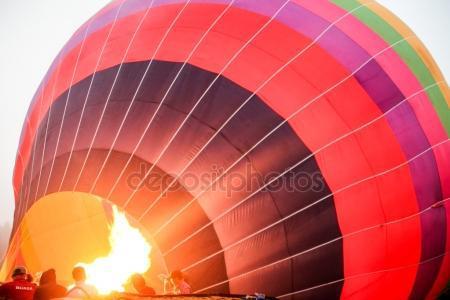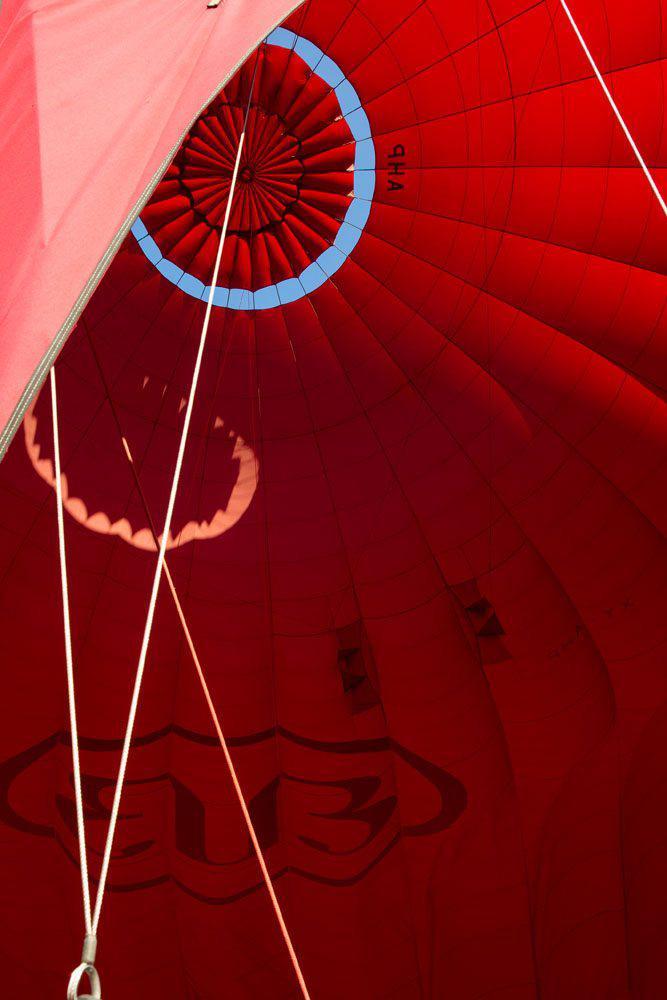The first image is the image on the left, the second image is the image on the right. For the images shown, is this caption "The fabric of the hot-air balloon in the left image features at least three colors." true? Answer yes or no. Yes. The first image is the image on the left, the second image is the image on the right. Analyze the images presented: Is the assertion "A blue circle design is at the top of the balloon on the right." valid? Answer yes or no. Yes. 